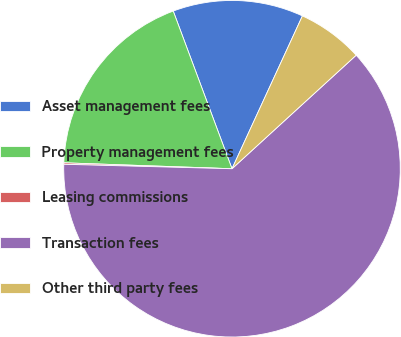Convert chart. <chart><loc_0><loc_0><loc_500><loc_500><pie_chart><fcel>Asset management fees<fcel>Property management fees<fcel>Leasing commissions<fcel>Transaction fees<fcel>Other third party fees<nl><fcel>12.55%<fcel>18.76%<fcel>0.14%<fcel>62.21%<fcel>6.34%<nl></chart> 